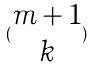Convert formula to latex. <formula><loc_0><loc_0><loc_500><loc_500>( \begin{matrix} m + 1 \\ k \end{matrix} )</formula> 